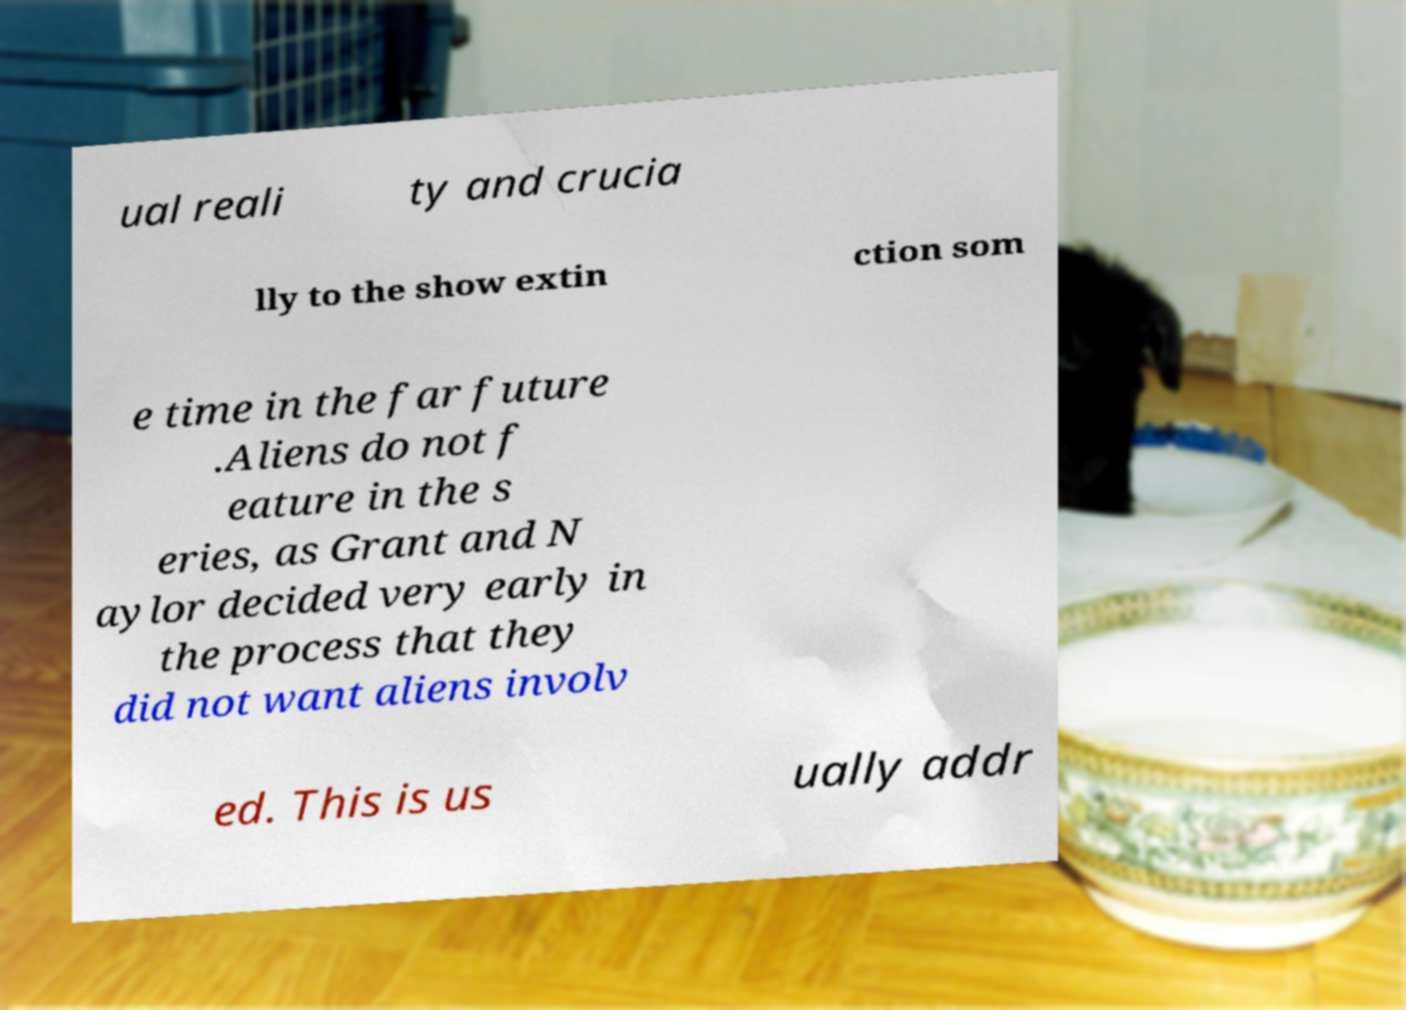Could you extract and type out the text from this image? ual reali ty and crucia lly to the show extin ction som e time in the far future .Aliens do not f eature in the s eries, as Grant and N aylor decided very early in the process that they did not want aliens involv ed. This is us ually addr 